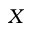<formula> <loc_0><loc_0><loc_500><loc_500>X</formula> 